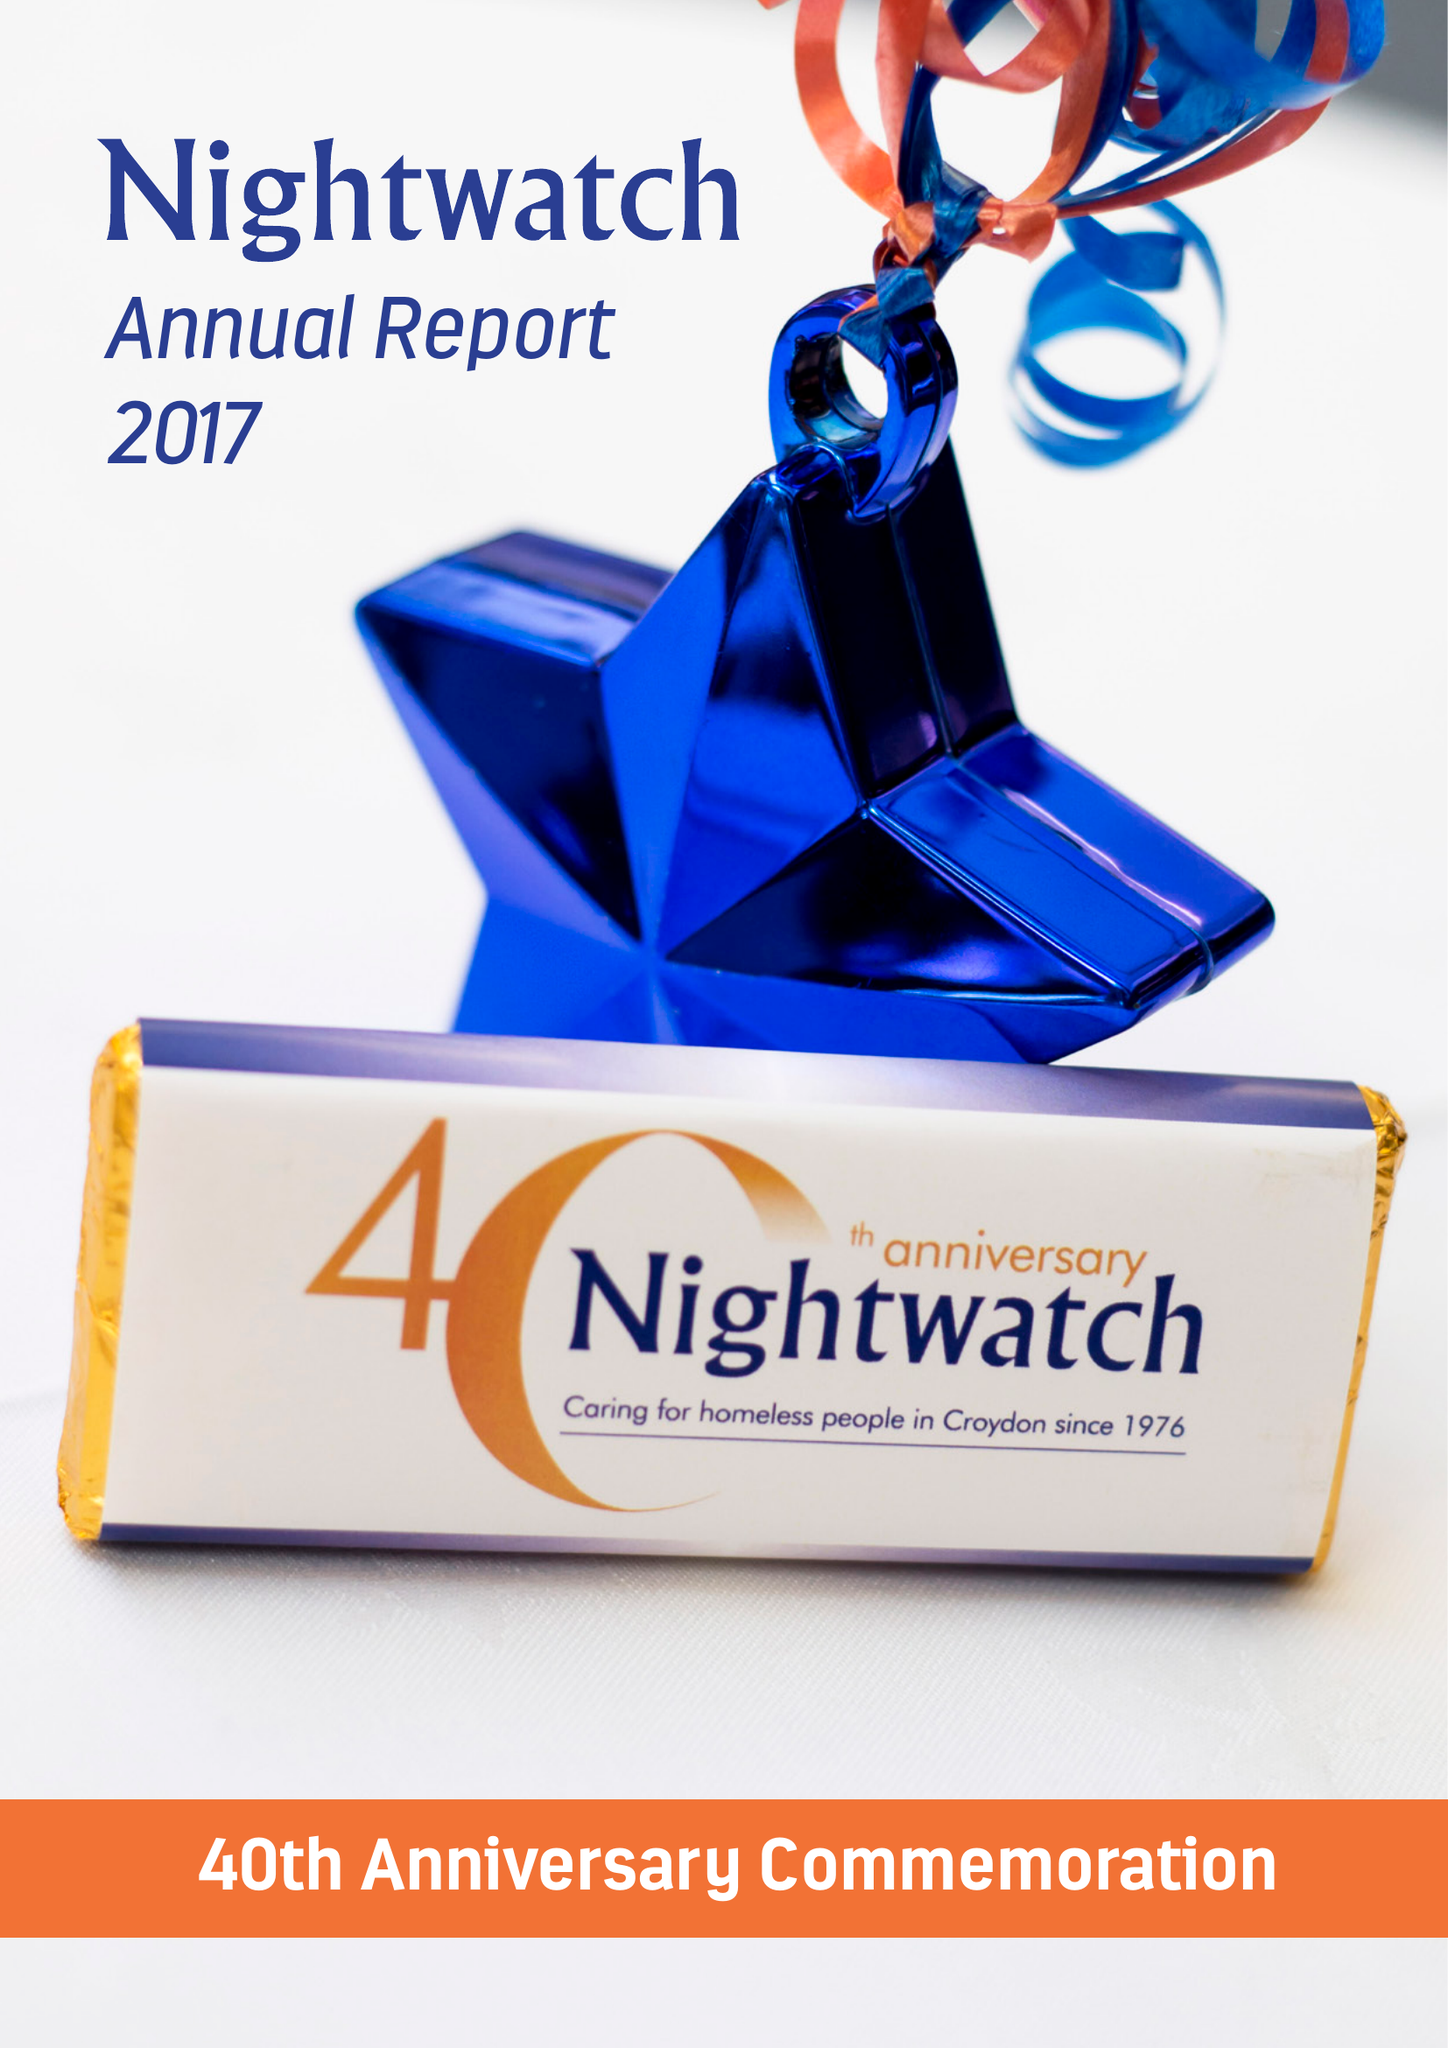What is the value for the address__street_line?
Answer the question using a single word or phrase. PO BOX 9576 